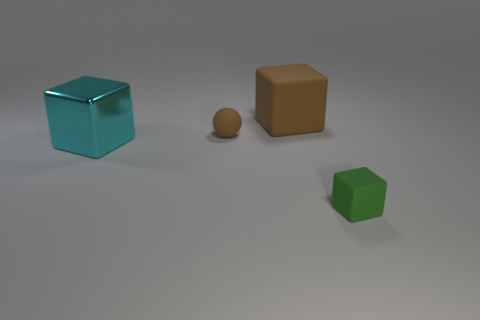What number of matte things are either large blue cubes or balls?
Ensure brevity in your answer.  1. Is there any other thing that has the same material as the big brown cube?
Make the answer very short. Yes. Do the big rubber thing and the tiny thing that is in front of the small matte sphere have the same color?
Your answer should be compact. No. The tiny brown object has what shape?
Your answer should be very brief. Sphere. What is the size of the rubber block that is in front of the tiny matte object behind the large block in front of the small brown sphere?
Provide a short and direct response. Small. How many other objects are the same shape as the metal object?
Offer a very short reply. 2. Do the small rubber object that is to the left of the small green thing and the large object behind the big cyan thing have the same shape?
Keep it short and to the point. No. What number of cylinders are either cyan things or red metallic objects?
Your answer should be compact. 0. What is the tiny object that is right of the large object right of the big object that is to the left of the big brown block made of?
Keep it short and to the point. Rubber. What number of other things are the same size as the cyan cube?
Your response must be concise. 1. 